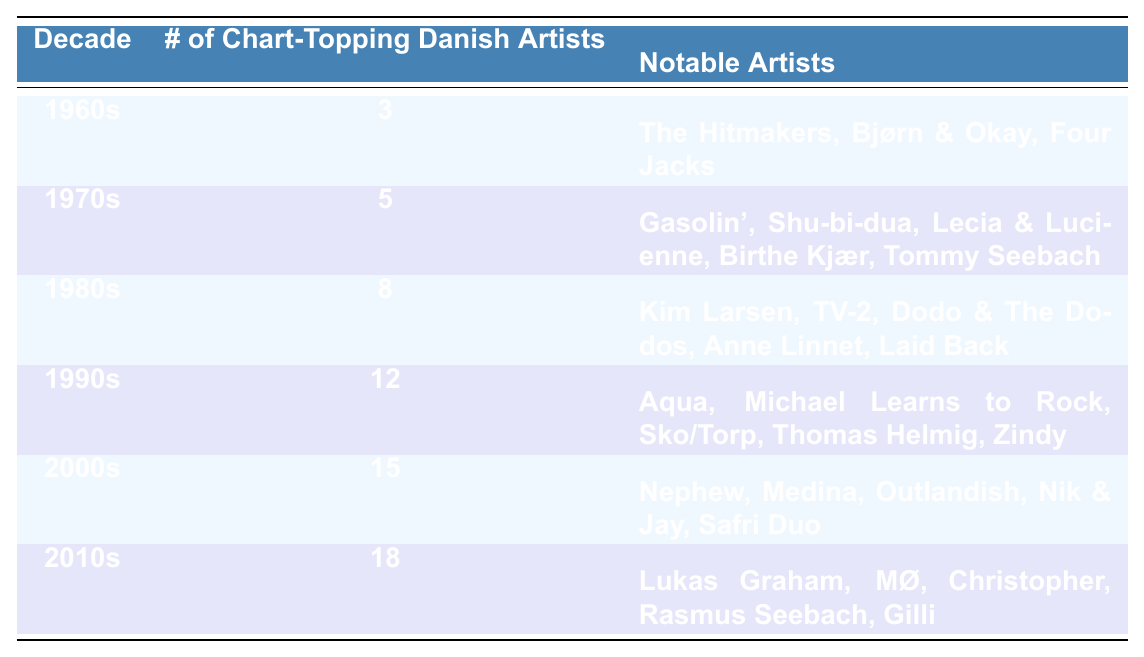What decade had the highest number of chart-topping Danish artists? Referring to the table, the 2010s had 18 chart-topping Danish artists, which is the highest number compared to the other decades listed.
Answer: 2010s How many chart-topping Danish artists were there in the 1980s? The table clearly states that there were 8 chart-topping Danish artists in the 1980s.
Answer: 8 Which notable artist is associated with the 1990s? According to the table, Aqua is a notable artist from the 1990s, as listed under that decade.
Answer: Aqua Did the number of chart-topping Danish artists increase every decade? Yes, after comparing the numbers in each decade (3 in the 1960s, 5 in the 1970s, etc.), it is clear that the number steadily increased every decade.
Answer: Yes What is the total number of chart-topping Danish artists across all decades listed? Adding up the artists from all decades: 3 + 5 + 8 + 12 + 15 + 18 = 61, resulting in a total of 61 chart-topping Danish artists.
Answer: 61 How many more chart-topping Danish artists were there in the 2000s compared to the 1960s? The 2000s had 15 chart-topping artists while the 1960s had 3. The difference is calculated as 15 - 3 = 12, meaning there were 12 more artists in the 2000s.
Answer: 12 Which decade saw a leap of more than 5 chart-topping Danish artists compared to the previous decade? From the 1990s (12 artists) to the 2000s (15 artists) is an increase of 3; however, the jump from the 2000s (15) to the 2010s (18) is only an increase of 3. The largest increase is from the 1980s (8) to 1990s (12), an increase of 4. None exceed 5.
Answer: None Which notable artists could be found in the decade with the lowest number of chart-topping Danish artists? The 1960s had the lowest number, which was 3 artists, and notable artists listed are The Hitmakers, Bjørn & Okay, and Four Jacks.
Answer: The Hitmakers, Bjørn & Okay, Four Jacks In which decade were the most notable artists listed? The 2010s not only had the highest number of chart-topping artists but also featured notable artists like Lukas Graham, MØ, Christopher, Rasmus Seebach, and Gilli, making it the decade with the most notable artists listed.
Answer: 2010s What was the average number of chart-topping Danish artists across all decades? Total number of artists is 61, as calculated above, and there are 6 decades. The average is thus 61 / 6 ≈ 10.17.
Answer: Approximately 10.17 